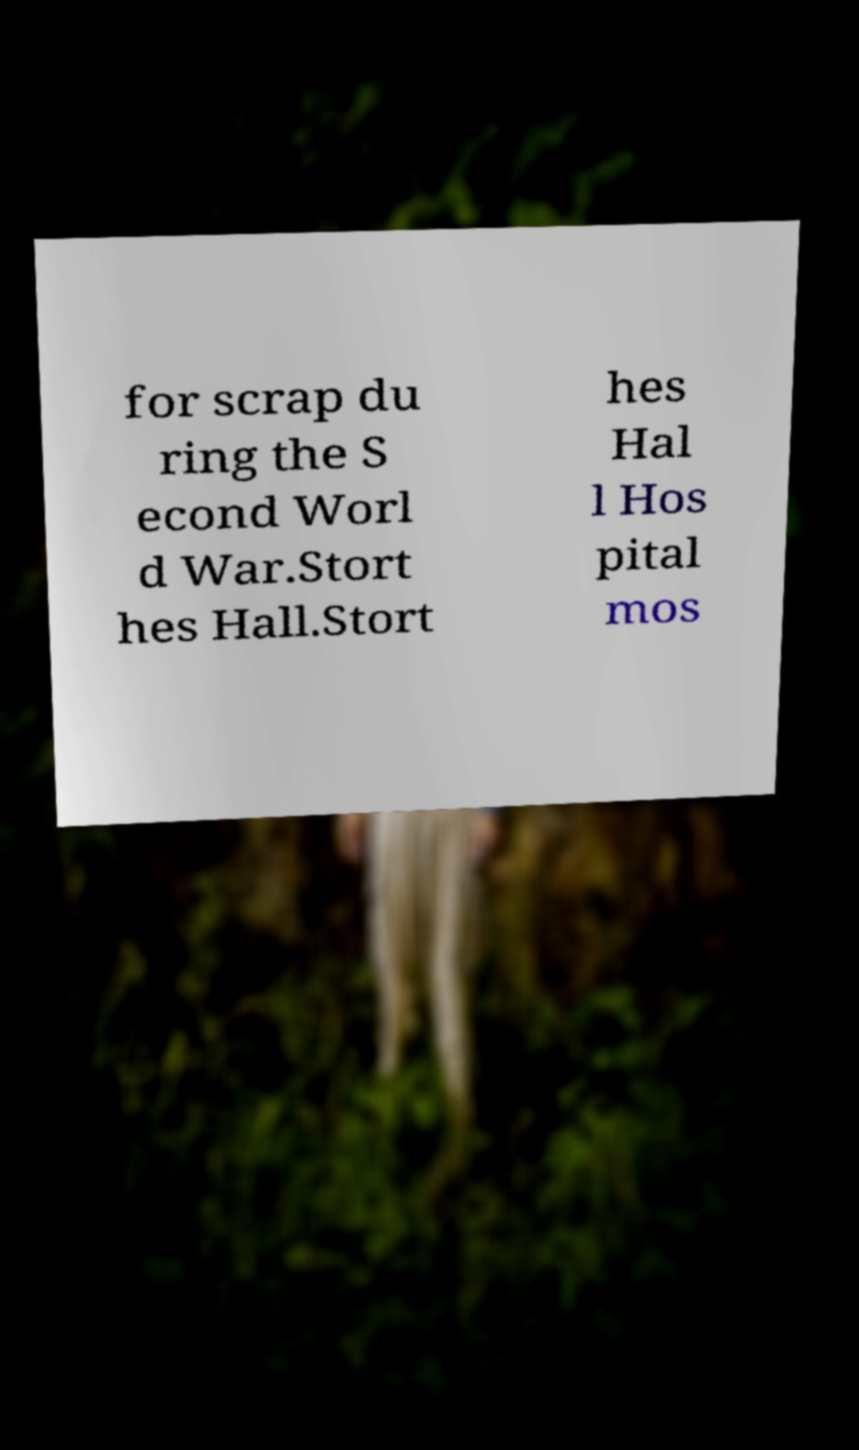I need the written content from this picture converted into text. Can you do that? for scrap du ring the S econd Worl d War.Stort hes Hall.Stort hes Hal l Hos pital mos 